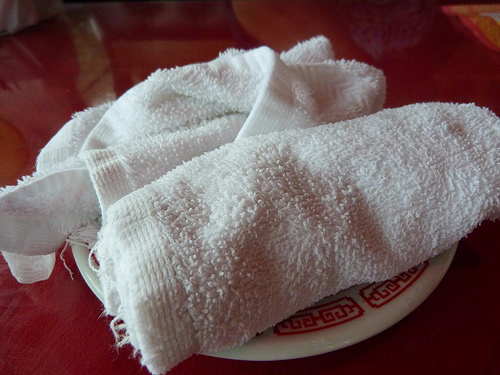<image>
Is there a towel on the table? No. The towel is not positioned on the table. They may be near each other, but the towel is not supported by or resting on top of the table. 